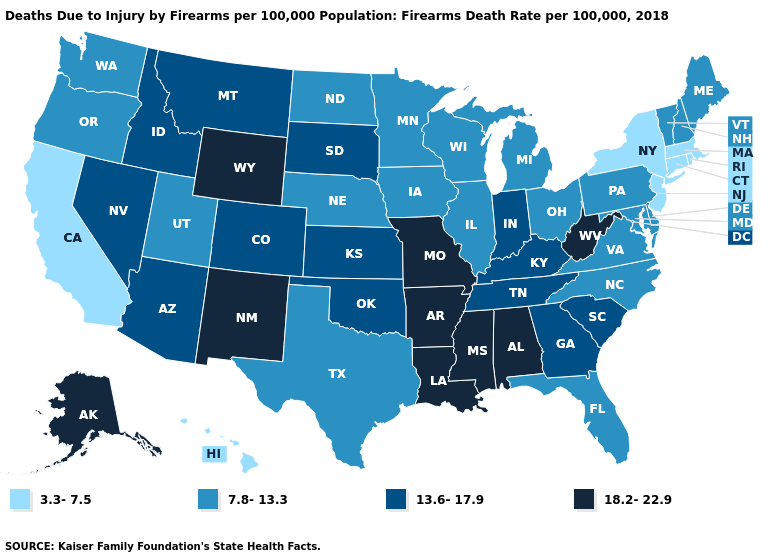What is the lowest value in states that border Kansas?
Give a very brief answer. 7.8-13.3. Name the states that have a value in the range 7.8-13.3?
Quick response, please. Delaware, Florida, Illinois, Iowa, Maine, Maryland, Michigan, Minnesota, Nebraska, New Hampshire, North Carolina, North Dakota, Ohio, Oregon, Pennsylvania, Texas, Utah, Vermont, Virginia, Washington, Wisconsin. Name the states that have a value in the range 18.2-22.9?
Be succinct. Alabama, Alaska, Arkansas, Louisiana, Mississippi, Missouri, New Mexico, West Virginia, Wyoming. What is the highest value in the South ?
Keep it brief. 18.2-22.9. Among the states that border Arizona , does New Mexico have the highest value?
Quick response, please. Yes. Name the states that have a value in the range 3.3-7.5?
Concise answer only. California, Connecticut, Hawaii, Massachusetts, New Jersey, New York, Rhode Island. What is the value of South Dakota?
Short answer required. 13.6-17.9. What is the highest value in the South ?
Give a very brief answer. 18.2-22.9. What is the value of Washington?
Be succinct. 7.8-13.3. Does Rhode Island have the lowest value in the Northeast?
Answer briefly. Yes. Which states have the lowest value in the USA?
Quick response, please. California, Connecticut, Hawaii, Massachusetts, New Jersey, New York, Rhode Island. Does Mississippi have the highest value in the USA?
Answer briefly. Yes. Which states have the lowest value in the USA?
Short answer required. California, Connecticut, Hawaii, Massachusetts, New Jersey, New York, Rhode Island. Among the states that border Georgia , which have the lowest value?
Be succinct. Florida, North Carolina. What is the lowest value in the Northeast?
Concise answer only. 3.3-7.5. 